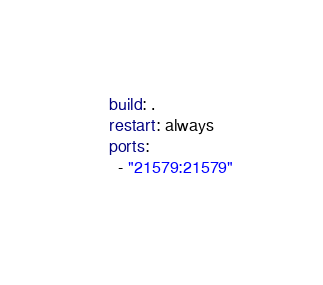Convert code to text. <code><loc_0><loc_0><loc_500><loc_500><_YAML_>    build: .
    restart: always
    ports:
      - "21579:21579"
    </code> 